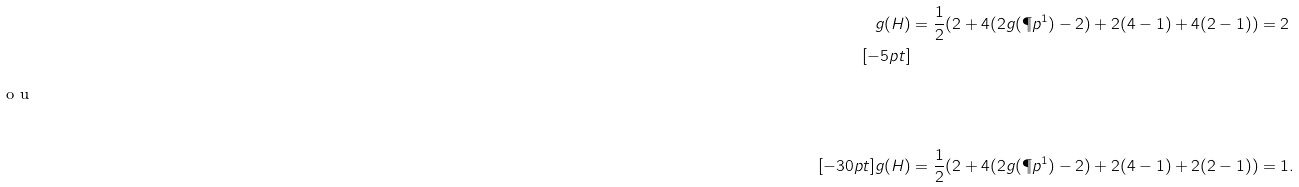<formula> <loc_0><loc_0><loc_500><loc_500>g ( H ) & = \frac { 1 } { 2 } ( 2 + 4 ( 2 g ( \P p ^ { 1 } ) - 2 ) + 2 ( 4 - 1 ) + 4 ( 2 - 1 ) ) = 2 \\ [ - 5 p t ] \intertext { o u } \\ [ - 3 0 p t ] g ( H ) & = \frac { 1 } { 2 } ( 2 + 4 ( 2 g ( \P p ^ { 1 } ) - 2 ) + 2 ( 4 - 1 ) + 2 ( 2 - 1 ) ) = 1 .</formula> 